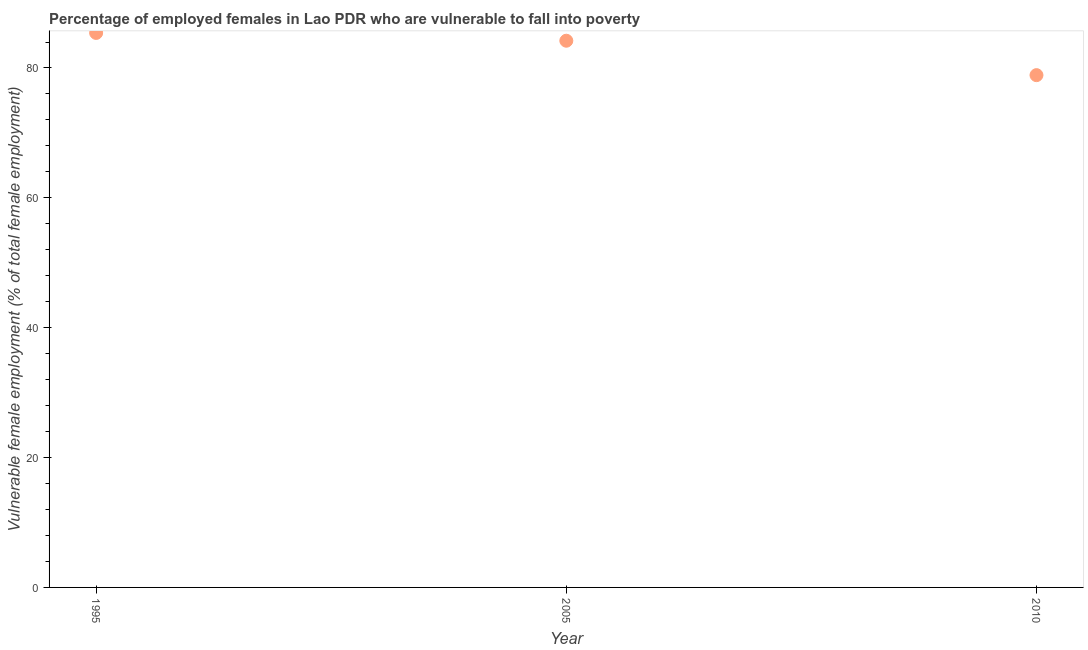What is the percentage of employed females who are vulnerable to fall into poverty in 1995?
Give a very brief answer. 85.4. Across all years, what is the maximum percentage of employed females who are vulnerable to fall into poverty?
Your answer should be compact. 85.4. Across all years, what is the minimum percentage of employed females who are vulnerable to fall into poverty?
Provide a short and direct response. 78.9. What is the sum of the percentage of employed females who are vulnerable to fall into poverty?
Give a very brief answer. 248.5. What is the difference between the percentage of employed females who are vulnerable to fall into poverty in 2005 and 2010?
Ensure brevity in your answer.  5.3. What is the average percentage of employed females who are vulnerable to fall into poverty per year?
Offer a very short reply. 82.83. What is the median percentage of employed females who are vulnerable to fall into poverty?
Give a very brief answer. 84.2. Do a majority of the years between 2005 and 1995 (inclusive) have percentage of employed females who are vulnerable to fall into poverty greater than 76 %?
Offer a terse response. No. What is the ratio of the percentage of employed females who are vulnerable to fall into poverty in 2005 to that in 2010?
Offer a very short reply. 1.07. Is the difference between the percentage of employed females who are vulnerable to fall into poverty in 1995 and 2010 greater than the difference between any two years?
Your response must be concise. Yes. What is the difference between the highest and the second highest percentage of employed females who are vulnerable to fall into poverty?
Ensure brevity in your answer.  1.2. Is the sum of the percentage of employed females who are vulnerable to fall into poverty in 2005 and 2010 greater than the maximum percentage of employed females who are vulnerable to fall into poverty across all years?
Provide a short and direct response. Yes. How many dotlines are there?
Give a very brief answer. 1. What is the difference between two consecutive major ticks on the Y-axis?
Keep it short and to the point. 20. Does the graph contain grids?
Provide a short and direct response. No. What is the title of the graph?
Offer a terse response. Percentage of employed females in Lao PDR who are vulnerable to fall into poverty. What is the label or title of the X-axis?
Offer a terse response. Year. What is the label or title of the Y-axis?
Offer a terse response. Vulnerable female employment (% of total female employment). What is the Vulnerable female employment (% of total female employment) in 1995?
Ensure brevity in your answer.  85.4. What is the Vulnerable female employment (% of total female employment) in 2005?
Make the answer very short. 84.2. What is the Vulnerable female employment (% of total female employment) in 2010?
Offer a very short reply. 78.9. What is the ratio of the Vulnerable female employment (% of total female employment) in 1995 to that in 2010?
Your response must be concise. 1.08. What is the ratio of the Vulnerable female employment (% of total female employment) in 2005 to that in 2010?
Keep it short and to the point. 1.07. 